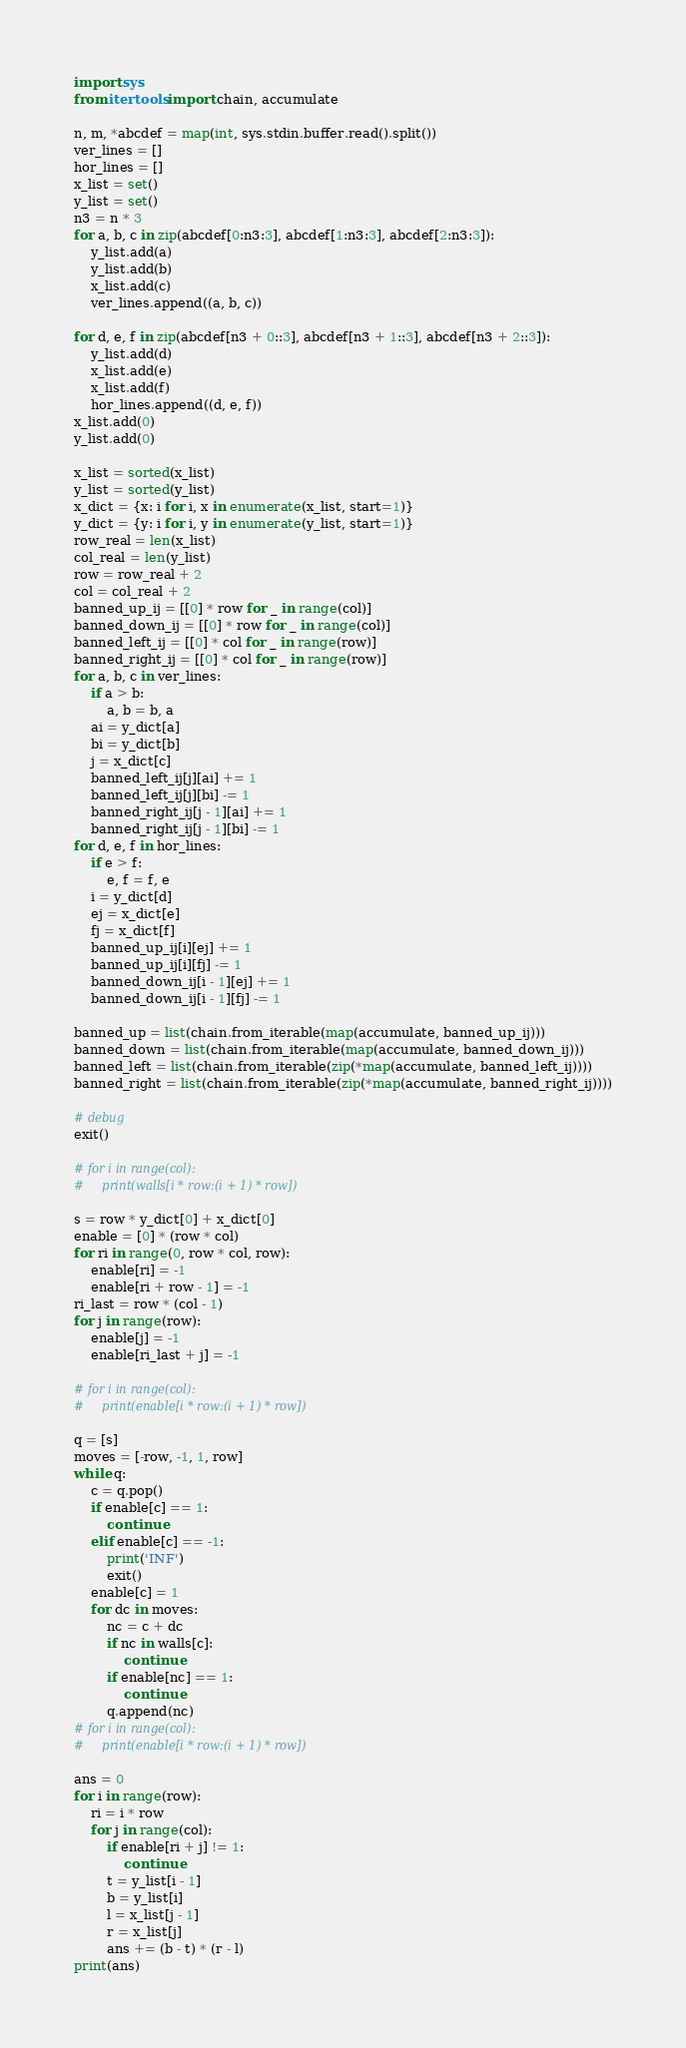<code> <loc_0><loc_0><loc_500><loc_500><_Python_>import sys
from itertools import chain, accumulate

n, m, *abcdef = map(int, sys.stdin.buffer.read().split())
ver_lines = []
hor_lines = []
x_list = set()
y_list = set()
n3 = n * 3
for a, b, c in zip(abcdef[0:n3:3], abcdef[1:n3:3], abcdef[2:n3:3]):
    y_list.add(a)
    y_list.add(b)
    x_list.add(c)
    ver_lines.append((a, b, c))

for d, e, f in zip(abcdef[n3 + 0::3], abcdef[n3 + 1::3], abcdef[n3 + 2::3]):
    y_list.add(d)
    x_list.add(e)
    x_list.add(f)
    hor_lines.append((d, e, f))
x_list.add(0)
y_list.add(0)

x_list = sorted(x_list)
y_list = sorted(y_list)
x_dict = {x: i for i, x in enumerate(x_list, start=1)}
y_dict = {y: i for i, y in enumerate(y_list, start=1)}
row_real = len(x_list)
col_real = len(y_list)
row = row_real + 2
col = col_real + 2
banned_up_ij = [[0] * row for _ in range(col)]
banned_down_ij = [[0] * row for _ in range(col)]
banned_left_ij = [[0] * col for _ in range(row)]
banned_right_ij = [[0] * col for _ in range(row)]
for a, b, c in ver_lines:
    if a > b:
        a, b = b, a
    ai = y_dict[a]
    bi = y_dict[b]
    j = x_dict[c]
    banned_left_ij[j][ai] += 1
    banned_left_ij[j][bi] -= 1
    banned_right_ij[j - 1][ai] += 1
    banned_right_ij[j - 1][bi] -= 1
for d, e, f in hor_lines:
    if e > f:
        e, f = f, e
    i = y_dict[d]
    ej = x_dict[e]
    fj = x_dict[f]
    banned_up_ij[i][ej] += 1
    banned_up_ij[i][fj] -= 1
    banned_down_ij[i - 1][ej] += 1
    banned_down_ij[i - 1][fj] -= 1

banned_up = list(chain.from_iterable(map(accumulate, banned_up_ij)))
banned_down = list(chain.from_iterable(map(accumulate, banned_down_ij)))
banned_left = list(chain.from_iterable(zip(*map(accumulate, banned_left_ij))))
banned_right = list(chain.from_iterable(zip(*map(accumulate, banned_right_ij))))

# debug
exit()

# for i in range(col):
#     print(walls[i * row:(i + 1) * row])

s = row * y_dict[0] + x_dict[0]
enable = [0] * (row * col)
for ri in range(0, row * col, row):
    enable[ri] = -1
    enable[ri + row - 1] = -1
ri_last = row * (col - 1)
for j in range(row):
    enable[j] = -1
    enable[ri_last + j] = -1

# for i in range(col):
#     print(enable[i * row:(i + 1) * row])

q = [s]
moves = [-row, -1, 1, row]
while q:
    c = q.pop()
    if enable[c] == 1:
        continue
    elif enable[c] == -1:
        print('INF')
        exit()
    enable[c] = 1
    for dc in moves:
        nc = c + dc
        if nc in walls[c]:
            continue
        if enable[nc] == 1:
            continue
        q.append(nc)
# for i in range(col):
#     print(enable[i * row:(i + 1) * row])

ans = 0
for i in range(row):
    ri = i * row
    for j in range(col):
        if enable[ri + j] != 1:
            continue
        t = y_list[i - 1]
        b = y_list[i]
        l = x_list[j - 1]
        r = x_list[j]
        ans += (b - t) * (r - l)
print(ans)
</code> 